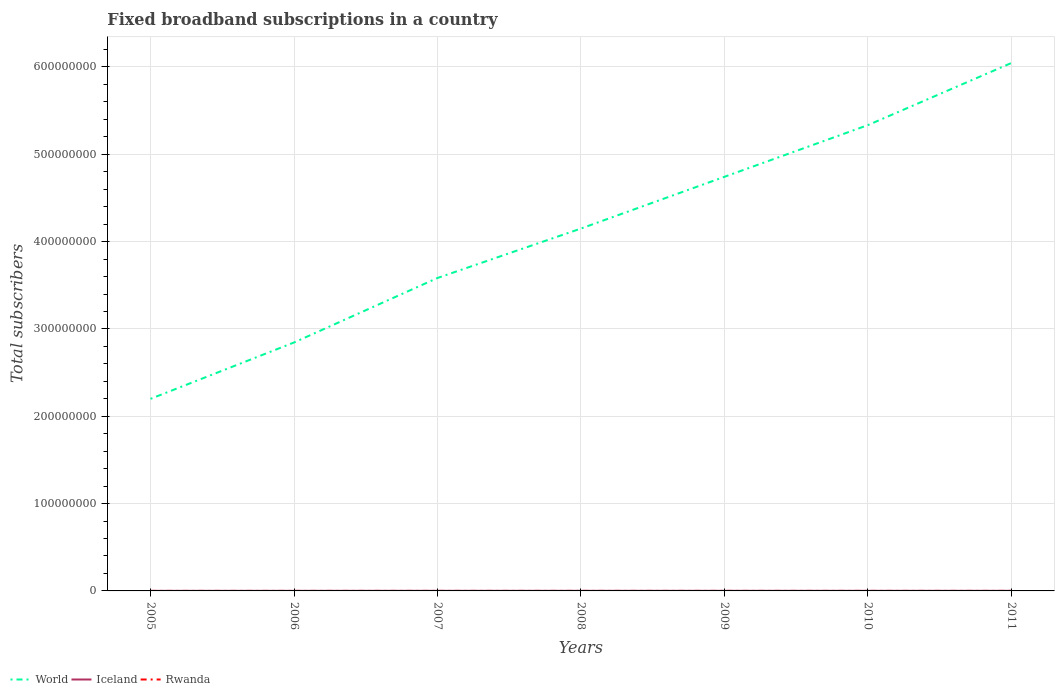Does the line corresponding to Rwanda intersect with the line corresponding to Iceland?
Give a very brief answer. No. Across all years, what is the maximum number of broadband subscriptions in World?
Offer a very short reply. 2.20e+08. What is the total number of broadband subscriptions in Iceland in the graph?
Your answer should be compact. -3.36e+04. What is the difference between the highest and the second highest number of broadband subscriptions in Rwanda?
Provide a succinct answer. 7525. What is the difference between the highest and the lowest number of broadband subscriptions in World?
Your answer should be very brief. 4. Is the number of broadband subscriptions in World strictly greater than the number of broadband subscriptions in Iceland over the years?
Give a very brief answer. No. How many years are there in the graph?
Provide a short and direct response. 7. Are the values on the major ticks of Y-axis written in scientific E-notation?
Your answer should be compact. No. Does the graph contain any zero values?
Your answer should be very brief. No. Does the graph contain grids?
Provide a short and direct response. Yes. Where does the legend appear in the graph?
Your response must be concise. Bottom left. What is the title of the graph?
Give a very brief answer. Fixed broadband subscriptions in a country. Does "Croatia" appear as one of the legend labels in the graph?
Your answer should be compact. No. What is the label or title of the X-axis?
Offer a very short reply. Years. What is the label or title of the Y-axis?
Ensure brevity in your answer.  Total subscribers. What is the Total subscribers of World in 2005?
Your response must be concise. 2.20e+08. What is the Total subscribers in Iceland in 2005?
Give a very brief answer. 7.80e+04. What is the Total subscribers in Rwanda in 2005?
Make the answer very short. 1180. What is the Total subscribers of World in 2006?
Provide a short and direct response. 2.85e+08. What is the Total subscribers in Iceland in 2006?
Keep it short and to the point. 8.77e+04. What is the Total subscribers of Rwanda in 2006?
Offer a very short reply. 1704. What is the Total subscribers of World in 2007?
Your response must be concise. 3.58e+08. What is the Total subscribers of Iceland in 2007?
Provide a short and direct response. 1.00e+05. What is the Total subscribers in Rwanda in 2007?
Your answer should be very brief. 2543. What is the Total subscribers of World in 2008?
Your response must be concise. 4.15e+08. What is the Total subscribers in Iceland in 2008?
Offer a very short reply. 1.06e+05. What is the Total subscribers in Rwanda in 2008?
Give a very brief answer. 1120. What is the Total subscribers in World in 2009?
Provide a short and direct response. 4.74e+08. What is the Total subscribers in Iceland in 2009?
Make the answer very short. 1.07e+05. What is the Total subscribers of Rwanda in 2009?
Offer a terse response. 2214. What is the Total subscribers in World in 2010?
Offer a terse response. 5.33e+08. What is the Total subscribers of Iceland in 2010?
Your answer should be very brief. 1.09e+05. What is the Total subscribers in Rwanda in 2010?
Make the answer very short. 3942. What is the Total subscribers of World in 2011?
Your answer should be very brief. 6.05e+08. What is the Total subscribers of Iceland in 2011?
Ensure brevity in your answer.  1.12e+05. What is the Total subscribers of Rwanda in 2011?
Your answer should be compact. 8645. Across all years, what is the maximum Total subscribers in World?
Your answer should be compact. 6.05e+08. Across all years, what is the maximum Total subscribers of Iceland?
Your response must be concise. 1.12e+05. Across all years, what is the maximum Total subscribers in Rwanda?
Provide a succinct answer. 8645. Across all years, what is the minimum Total subscribers of World?
Your answer should be very brief. 2.20e+08. Across all years, what is the minimum Total subscribers of Iceland?
Offer a terse response. 7.80e+04. Across all years, what is the minimum Total subscribers in Rwanda?
Offer a terse response. 1120. What is the total Total subscribers of World in the graph?
Offer a very short reply. 2.89e+09. What is the total Total subscribers in Iceland in the graph?
Your answer should be very brief. 7.00e+05. What is the total Total subscribers of Rwanda in the graph?
Give a very brief answer. 2.13e+04. What is the difference between the Total subscribers of World in 2005 and that in 2006?
Ensure brevity in your answer.  -6.45e+07. What is the difference between the Total subscribers of Iceland in 2005 and that in 2006?
Offer a terse response. -9721. What is the difference between the Total subscribers in Rwanda in 2005 and that in 2006?
Make the answer very short. -524. What is the difference between the Total subscribers of World in 2005 and that in 2007?
Ensure brevity in your answer.  -1.38e+08. What is the difference between the Total subscribers of Iceland in 2005 and that in 2007?
Offer a terse response. -2.20e+04. What is the difference between the Total subscribers of Rwanda in 2005 and that in 2007?
Your answer should be compact. -1363. What is the difference between the Total subscribers in World in 2005 and that in 2008?
Your response must be concise. -1.95e+08. What is the difference between the Total subscribers in Iceland in 2005 and that in 2008?
Your answer should be very brief. -2.80e+04. What is the difference between the Total subscribers in World in 2005 and that in 2009?
Give a very brief answer. -2.54e+08. What is the difference between the Total subscribers in Iceland in 2005 and that in 2009?
Give a very brief answer. -2.91e+04. What is the difference between the Total subscribers of Rwanda in 2005 and that in 2009?
Give a very brief answer. -1034. What is the difference between the Total subscribers in World in 2005 and that in 2010?
Your answer should be very brief. -3.14e+08. What is the difference between the Total subscribers in Iceland in 2005 and that in 2010?
Your response must be concise. -3.12e+04. What is the difference between the Total subscribers of Rwanda in 2005 and that in 2010?
Ensure brevity in your answer.  -2762. What is the difference between the Total subscribers in World in 2005 and that in 2011?
Your answer should be very brief. -3.85e+08. What is the difference between the Total subscribers in Iceland in 2005 and that in 2011?
Your answer should be compact. -3.36e+04. What is the difference between the Total subscribers in Rwanda in 2005 and that in 2011?
Give a very brief answer. -7465. What is the difference between the Total subscribers of World in 2006 and that in 2007?
Your answer should be very brief. -7.39e+07. What is the difference between the Total subscribers in Iceland in 2006 and that in 2007?
Make the answer very short. -1.23e+04. What is the difference between the Total subscribers in Rwanda in 2006 and that in 2007?
Your answer should be compact. -839. What is the difference between the Total subscribers in World in 2006 and that in 2008?
Provide a succinct answer. -1.31e+08. What is the difference between the Total subscribers of Iceland in 2006 and that in 2008?
Give a very brief answer. -1.83e+04. What is the difference between the Total subscribers of Rwanda in 2006 and that in 2008?
Offer a terse response. 584. What is the difference between the Total subscribers in World in 2006 and that in 2009?
Provide a succinct answer. -1.90e+08. What is the difference between the Total subscribers of Iceland in 2006 and that in 2009?
Your response must be concise. -1.93e+04. What is the difference between the Total subscribers of Rwanda in 2006 and that in 2009?
Your answer should be very brief. -510. What is the difference between the Total subscribers of World in 2006 and that in 2010?
Offer a terse response. -2.49e+08. What is the difference between the Total subscribers in Iceland in 2006 and that in 2010?
Give a very brief answer. -2.15e+04. What is the difference between the Total subscribers of Rwanda in 2006 and that in 2010?
Your answer should be very brief. -2238. What is the difference between the Total subscribers of World in 2006 and that in 2011?
Your response must be concise. -3.20e+08. What is the difference between the Total subscribers of Iceland in 2006 and that in 2011?
Provide a succinct answer. -2.38e+04. What is the difference between the Total subscribers of Rwanda in 2006 and that in 2011?
Your answer should be very brief. -6941. What is the difference between the Total subscribers in World in 2007 and that in 2008?
Provide a short and direct response. -5.66e+07. What is the difference between the Total subscribers of Iceland in 2007 and that in 2008?
Your answer should be very brief. -5991. What is the difference between the Total subscribers of Rwanda in 2007 and that in 2008?
Your response must be concise. 1423. What is the difference between the Total subscribers of World in 2007 and that in 2009?
Make the answer very short. -1.16e+08. What is the difference between the Total subscribers of Iceland in 2007 and that in 2009?
Offer a terse response. -7046. What is the difference between the Total subscribers of Rwanda in 2007 and that in 2009?
Provide a short and direct response. 329. What is the difference between the Total subscribers in World in 2007 and that in 2010?
Offer a terse response. -1.75e+08. What is the difference between the Total subscribers of Iceland in 2007 and that in 2010?
Your answer should be compact. -9186. What is the difference between the Total subscribers in Rwanda in 2007 and that in 2010?
Your response must be concise. -1399. What is the difference between the Total subscribers of World in 2007 and that in 2011?
Offer a very short reply. -2.46e+08. What is the difference between the Total subscribers of Iceland in 2007 and that in 2011?
Your answer should be compact. -1.16e+04. What is the difference between the Total subscribers in Rwanda in 2007 and that in 2011?
Give a very brief answer. -6102. What is the difference between the Total subscribers of World in 2008 and that in 2009?
Provide a short and direct response. -5.92e+07. What is the difference between the Total subscribers of Iceland in 2008 and that in 2009?
Offer a very short reply. -1055. What is the difference between the Total subscribers in Rwanda in 2008 and that in 2009?
Give a very brief answer. -1094. What is the difference between the Total subscribers of World in 2008 and that in 2010?
Your answer should be compact. -1.18e+08. What is the difference between the Total subscribers in Iceland in 2008 and that in 2010?
Offer a terse response. -3195. What is the difference between the Total subscribers of Rwanda in 2008 and that in 2010?
Provide a succinct answer. -2822. What is the difference between the Total subscribers of World in 2008 and that in 2011?
Offer a very short reply. -1.90e+08. What is the difference between the Total subscribers in Iceland in 2008 and that in 2011?
Make the answer very short. -5567. What is the difference between the Total subscribers of Rwanda in 2008 and that in 2011?
Give a very brief answer. -7525. What is the difference between the Total subscribers of World in 2009 and that in 2010?
Offer a terse response. -5.92e+07. What is the difference between the Total subscribers in Iceland in 2009 and that in 2010?
Ensure brevity in your answer.  -2140. What is the difference between the Total subscribers of Rwanda in 2009 and that in 2010?
Ensure brevity in your answer.  -1728. What is the difference between the Total subscribers in World in 2009 and that in 2011?
Make the answer very short. -1.30e+08. What is the difference between the Total subscribers of Iceland in 2009 and that in 2011?
Your answer should be very brief. -4512. What is the difference between the Total subscribers in Rwanda in 2009 and that in 2011?
Offer a very short reply. -6431. What is the difference between the Total subscribers of World in 2010 and that in 2011?
Ensure brevity in your answer.  -7.11e+07. What is the difference between the Total subscribers in Iceland in 2010 and that in 2011?
Keep it short and to the point. -2372. What is the difference between the Total subscribers of Rwanda in 2010 and that in 2011?
Provide a succinct answer. -4703. What is the difference between the Total subscribers in World in 2005 and the Total subscribers in Iceland in 2006?
Your answer should be very brief. 2.20e+08. What is the difference between the Total subscribers in World in 2005 and the Total subscribers in Rwanda in 2006?
Offer a terse response. 2.20e+08. What is the difference between the Total subscribers in Iceland in 2005 and the Total subscribers in Rwanda in 2006?
Your answer should be very brief. 7.63e+04. What is the difference between the Total subscribers in World in 2005 and the Total subscribers in Iceland in 2007?
Your answer should be very brief. 2.20e+08. What is the difference between the Total subscribers in World in 2005 and the Total subscribers in Rwanda in 2007?
Provide a short and direct response. 2.20e+08. What is the difference between the Total subscribers of Iceland in 2005 and the Total subscribers of Rwanda in 2007?
Keep it short and to the point. 7.55e+04. What is the difference between the Total subscribers in World in 2005 and the Total subscribers in Iceland in 2008?
Offer a terse response. 2.20e+08. What is the difference between the Total subscribers of World in 2005 and the Total subscribers of Rwanda in 2008?
Make the answer very short. 2.20e+08. What is the difference between the Total subscribers of Iceland in 2005 and the Total subscribers of Rwanda in 2008?
Provide a short and direct response. 7.69e+04. What is the difference between the Total subscribers in World in 2005 and the Total subscribers in Iceland in 2009?
Your answer should be compact. 2.20e+08. What is the difference between the Total subscribers of World in 2005 and the Total subscribers of Rwanda in 2009?
Your answer should be very brief. 2.20e+08. What is the difference between the Total subscribers of Iceland in 2005 and the Total subscribers of Rwanda in 2009?
Give a very brief answer. 7.58e+04. What is the difference between the Total subscribers in World in 2005 and the Total subscribers in Iceland in 2010?
Make the answer very short. 2.20e+08. What is the difference between the Total subscribers of World in 2005 and the Total subscribers of Rwanda in 2010?
Offer a terse response. 2.20e+08. What is the difference between the Total subscribers in Iceland in 2005 and the Total subscribers in Rwanda in 2010?
Provide a short and direct response. 7.41e+04. What is the difference between the Total subscribers of World in 2005 and the Total subscribers of Iceland in 2011?
Your answer should be compact. 2.20e+08. What is the difference between the Total subscribers in World in 2005 and the Total subscribers in Rwanda in 2011?
Provide a short and direct response. 2.20e+08. What is the difference between the Total subscribers in Iceland in 2005 and the Total subscribers in Rwanda in 2011?
Give a very brief answer. 6.94e+04. What is the difference between the Total subscribers of World in 2006 and the Total subscribers of Iceland in 2007?
Ensure brevity in your answer.  2.84e+08. What is the difference between the Total subscribers of World in 2006 and the Total subscribers of Rwanda in 2007?
Provide a short and direct response. 2.85e+08. What is the difference between the Total subscribers in Iceland in 2006 and the Total subscribers in Rwanda in 2007?
Your answer should be very brief. 8.52e+04. What is the difference between the Total subscribers in World in 2006 and the Total subscribers in Iceland in 2008?
Make the answer very short. 2.84e+08. What is the difference between the Total subscribers of World in 2006 and the Total subscribers of Rwanda in 2008?
Offer a very short reply. 2.85e+08. What is the difference between the Total subscribers in Iceland in 2006 and the Total subscribers in Rwanda in 2008?
Offer a terse response. 8.66e+04. What is the difference between the Total subscribers in World in 2006 and the Total subscribers in Iceland in 2009?
Your response must be concise. 2.84e+08. What is the difference between the Total subscribers of World in 2006 and the Total subscribers of Rwanda in 2009?
Ensure brevity in your answer.  2.85e+08. What is the difference between the Total subscribers of Iceland in 2006 and the Total subscribers of Rwanda in 2009?
Offer a terse response. 8.55e+04. What is the difference between the Total subscribers of World in 2006 and the Total subscribers of Iceland in 2010?
Your answer should be very brief. 2.84e+08. What is the difference between the Total subscribers of World in 2006 and the Total subscribers of Rwanda in 2010?
Make the answer very short. 2.85e+08. What is the difference between the Total subscribers in Iceland in 2006 and the Total subscribers in Rwanda in 2010?
Keep it short and to the point. 8.38e+04. What is the difference between the Total subscribers of World in 2006 and the Total subscribers of Iceland in 2011?
Offer a terse response. 2.84e+08. What is the difference between the Total subscribers of World in 2006 and the Total subscribers of Rwanda in 2011?
Offer a terse response. 2.84e+08. What is the difference between the Total subscribers of Iceland in 2006 and the Total subscribers of Rwanda in 2011?
Ensure brevity in your answer.  7.91e+04. What is the difference between the Total subscribers of World in 2007 and the Total subscribers of Iceland in 2008?
Give a very brief answer. 3.58e+08. What is the difference between the Total subscribers in World in 2007 and the Total subscribers in Rwanda in 2008?
Provide a succinct answer. 3.58e+08. What is the difference between the Total subscribers of Iceland in 2007 and the Total subscribers of Rwanda in 2008?
Your answer should be compact. 9.89e+04. What is the difference between the Total subscribers in World in 2007 and the Total subscribers in Iceland in 2009?
Your answer should be compact. 3.58e+08. What is the difference between the Total subscribers of World in 2007 and the Total subscribers of Rwanda in 2009?
Give a very brief answer. 3.58e+08. What is the difference between the Total subscribers of Iceland in 2007 and the Total subscribers of Rwanda in 2009?
Keep it short and to the point. 9.78e+04. What is the difference between the Total subscribers in World in 2007 and the Total subscribers in Iceland in 2010?
Your answer should be compact. 3.58e+08. What is the difference between the Total subscribers of World in 2007 and the Total subscribers of Rwanda in 2010?
Provide a succinct answer. 3.58e+08. What is the difference between the Total subscribers of Iceland in 2007 and the Total subscribers of Rwanda in 2010?
Your answer should be very brief. 9.61e+04. What is the difference between the Total subscribers of World in 2007 and the Total subscribers of Iceland in 2011?
Your answer should be very brief. 3.58e+08. What is the difference between the Total subscribers in World in 2007 and the Total subscribers in Rwanda in 2011?
Provide a short and direct response. 3.58e+08. What is the difference between the Total subscribers of Iceland in 2007 and the Total subscribers of Rwanda in 2011?
Provide a succinct answer. 9.14e+04. What is the difference between the Total subscribers of World in 2008 and the Total subscribers of Iceland in 2009?
Keep it short and to the point. 4.15e+08. What is the difference between the Total subscribers in World in 2008 and the Total subscribers in Rwanda in 2009?
Make the answer very short. 4.15e+08. What is the difference between the Total subscribers in Iceland in 2008 and the Total subscribers in Rwanda in 2009?
Offer a terse response. 1.04e+05. What is the difference between the Total subscribers in World in 2008 and the Total subscribers in Iceland in 2010?
Ensure brevity in your answer.  4.15e+08. What is the difference between the Total subscribers in World in 2008 and the Total subscribers in Rwanda in 2010?
Provide a succinct answer. 4.15e+08. What is the difference between the Total subscribers in Iceland in 2008 and the Total subscribers in Rwanda in 2010?
Your response must be concise. 1.02e+05. What is the difference between the Total subscribers in World in 2008 and the Total subscribers in Iceland in 2011?
Your answer should be compact. 4.15e+08. What is the difference between the Total subscribers of World in 2008 and the Total subscribers of Rwanda in 2011?
Provide a short and direct response. 4.15e+08. What is the difference between the Total subscribers in Iceland in 2008 and the Total subscribers in Rwanda in 2011?
Ensure brevity in your answer.  9.74e+04. What is the difference between the Total subscribers in World in 2009 and the Total subscribers in Iceland in 2010?
Ensure brevity in your answer.  4.74e+08. What is the difference between the Total subscribers in World in 2009 and the Total subscribers in Rwanda in 2010?
Provide a short and direct response. 4.74e+08. What is the difference between the Total subscribers in Iceland in 2009 and the Total subscribers in Rwanda in 2010?
Your answer should be compact. 1.03e+05. What is the difference between the Total subscribers of World in 2009 and the Total subscribers of Iceland in 2011?
Offer a terse response. 4.74e+08. What is the difference between the Total subscribers of World in 2009 and the Total subscribers of Rwanda in 2011?
Ensure brevity in your answer.  4.74e+08. What is the difference between the Total subscribers of Iceland in 2009 and the Total subscribers of Rwanda in 2011?
Provide a succinct answer. 9.84e+04. What is the difference between the Total subscribers of World in 2010 and the Total subscribers of Iceland in 2011?
Your answer should be compact. 5.33e+08. What is the difference between the Total subscribers in World in 2010 and the Total subscribers in Rwanda in 2011?
Give a very brief answer. 5.33e+08. What is the difference between the Total subscribers of Iceland in 2010 and the Total subscribers of Rwanda in 2011?
Make the answer very short. 1.01e+05. What is the average Total subscribers in World per year?
Provide a succinct answer. 4.13e+08. What is the average Total subscribers of Iceland per year?
Your answer should be compact. 1.00e+05. What is the average Total subscribers in Rwanda per year?
Your answer should be very brief. 3049.71. In the year 2005, what is the difference between the Total subscribers in World and Total subscribers in Iceland?
Keep it short and to the point. 2.20e+08. In the year 2005, what is the difference between the Total subscribers in World and Total subscribers in Rwanda?
Keep it short and to the point. 2.20e+08. In the year 2005, what is the difference between the Total subscribers in Iceland and Total subscribers in Rwanda?
Provide a succinct answer. 7.68e+04. In the year 2006, what is the difference between the Total subscribers of World and Total subscribers of Iceland?
Provide a short and direct response. 2.84e+08. In the year 2006, what is the difference between the Total subscribers of World and Total subscribers of Rwanda?
Provide a succinct answer. 2.85e+08. In the year 2006, what is the difference between the Total subscribers of Iceland and Total subscribers of Rwanda?
Your response must be concise. 8.60e+04. In the year 2007, what is the difference between the Total subscribers in World and Total subscribers in Iceland?
Offer a terse response. 3.58e+08. In the year 2007, what is the difference between the Total subscribers in World and Total subscribers in Rwanda?
Offer a terse response. 3.58e+08. In the year 2007, what is the difference between the Total subscribers in Iceland and Total subscribers in Rwanda?
Keep it short and to the point. 9.75e+04. In the year 2008, what is the difference between the Total subscribers of World and Total subscribers of Iceland?
Offer a terse response. 4.15e+08. In the year 2008, what is the difference between the Total subscribers of World and Total subscribers of Rwanda?
Provide a succinct answer. 4.15e+08. In the year 2008, what is the difference between the Total subscribers of Iceland and Total subscribers of Rwanda?
Ensure brevity in your answer.  1.05e+05. In the year 2009, what is the difference between the Total subscribers of World and Total subscribers of Iceland?
Keep it short and to the point. 4.74e+08. In the year 2009, what is the difference between the Total subscribers in World and Total subscribers in Rwanda?
Your answer should be very brief. 4.74e+08. In the year 2009, what is the difference between the Total subscribers in Iceland and Total subscribers in Rwanda?
Offer a very short reply. 1.05e+05. In the year 2010, what is the difference between the Total subscribers of World and Total subscribers of Iceland?
Provide a succinct answer. 5.33e+08. In the year 2010, what is the difference between the Total subscribers in World and Total subscribers in Rwanda?
Offer a very short reply. 5.33e+08. In the year 2010, what is the difference between the Total subscribers in Iceland and Total subscribers in Rwanda?
Ensure brevity in your answer.  1.05e+05. In the year 2011, what is the difference between the Total subscribers of World and Total subscribers of Iceland?
Provide a short and direct response. 6.04e+08. In the year 2011, what is the difference between the Total subscribers in World and Total subscribers in Rwanda?
Ensure brevity in your answer.  6.05e+08. In the year 2011, what is the difference between the Total subscribers of Iceland and Total subscribers of Rwanda?
Your answer should be very brief. 1.03e+05. What is the ratio of the Total subscribers of World in 2005 to that in 2006?
Provide a succinct answer. 0.77. What is the ratio of the Total subscribers in Iceland in 2005 to that in 2006?
Provide a succinct answer. 0.89. What is the ratio of the Total subscribers of Rwanda in 2005 to that in 2006?
Your answer should be very brief. 0.69. What is the ratio of the Total subscribers of World in 2005 to that in 2007?
Your answer should be very brief. 0.61. What is the ratio of the Total subscribers in Iceland in 2005 to that in 2007?
Give a very brief answer. 0.78. What is the ratio of the Total subscribers in Rwanda in 2005 to that in 2007?
Keep it short and to the point. 0.46. What is the ratio of the Total subscribers in World in 2005 to that in 2008?
Provide a short and direct response. 0.53. What is the ratio of the Total subscribers in Iceland in 2005 to that in 2008?
Your answer should be very brief. 0.74. What is the ratio of the Total subscribers of Rwanda in 2005 to that in 2008?
Offer a terse response. 1.05. What is the ratio of the Total subscribers in World in 2005 to that in 2009?
Offer a very short reply. 0.46. What is the ratio of the Total subscribers in Iceland in 2005 to that in 2009?
Provide a short and direct response. 0.73. What is the ratio of the Total subscribers in Rwanda in 2005 to that in 2009?
Your response must be concise. 0.53. What is the ratio of the Total subscribers of World in 2005 to that in 2010?
Your answer should be very brief. 0.41. What is the ratio of the Total subscribers in Iceland in 2005 to that in 2010?
Provide a succinct answer. 0.71. What is the ratio of the Total subscribers of Rwanda in 2005 to that in 2010?
Ensure brevity in your answer.  0.3. What is the ratio of the Total subscribers in World in 2005 to that in 2011?
Your answer should be compact. 0.36. What is the ratio of the Total subscribers of Iceland in 2005 to that in 2011?
Your answer should be compact. 0.7. What is the ratio of the Total subscribers of Rwanda in 2005 to that in 2011?
Give a very brief answer. 0.14. What is the ratio of the Total subscribers in World in 2006 to that in 2007?
Provide a succinct answer. 0.79. What is the ratio of the Total subscribers of Iceland in 2006 to that in 2007?
Make the answer very short. 0.88. What is the ratio of the Total subscribers of Rwanda in 2006 to that in 2007?
Offer a terse response. 0.67. What is the ratio of the Total subscribers of World in 2006 to that in 2008?
Keep it short and to the point. 0.69. What is the ratio of the Total subscribers of Iceland in 2006 to that in 2008?
Give a very brief answer. 0.83. What is the ratio of the Total subscribers of Rwanda in 2006 to that in 2008?
Offer a very short reply. 1.52. What is the ratio of the Total subscribers of World in 2006 to that in 2009?
Your answer should be compact. 0.6. What is the ratio of the Total subscribers of Iceland in 2006 to that in 2009?
Provide a short and direct response. 0.82. What is the ratio of the Total subscribers in Rwanda in 2006 to that in 2009?
Your answer should be very brief. 0.77. What is the ratio of the Total subscribers of World in 2006 to that in 2010?
Give a very brief answer. 0.53. What is the ratio of the Total subscribers of Iceland in 2006 to that in 2010?
Your answer should be compact. 0.8. What is the ratio of the Total subscribers in Rwanda in 2006 to that in 2010?
Ensure brevity in your answer.  0.43. What is the ratio of the Total subscribers of World in 2006 to that in 2011?
Your answer should be very brief. 0.47. What is the ratio of the Total subscribers in Iceland in 2006 to that in 2011?
Your response must be concise. 0.79. What is the ratio of the Total subscribers of Rwanda in 2006 to that in 2011?
Keep it short and to the point. 0.2. What is the ratio of the Total subscribers in World in 2007 to that in 2008?
Your answer should be very brief. 0.86. What is the ratio of the Total subscribers of Iceland in 2007 to that in 2008?
Offer a very short reply. 0.94. What is the ratio of the Total subscribers of Rwanda in 2007 to that in 2008?
Keep it short and to the point. 2.27. What is the ratio of the Total subscribers of World in 2007 to that in 2009?
Provide a short and direct response. 0.76. What is the ratio of the Total subscribers of Iceland in 2007 to that in 2009?
Give a very brief answer. 0.93. What is the ratio of the Total subscribers in Rwanda in 2007 to that in 2009?
Provide a succinct answer. 1.15. What is the ratio of the Total subscribers of World in 2007 to that in 2010?
Make the answer very short. 0.67. What is the ratio of the Total subscribers of Iceland in 2007 to that in 2010?
Give a very brief answer. 0.92. What is the ratio of the Total subscribers of Rwanda in 2007 to that in 2010?
Provide a succinct answer. 0.65. What is the ratio of the Total subscribers in World in 2007 to that in 2011?
Offer a terse response. 0.59. What is the ratio of the Total subscribers of Iceland in 2007 to that in 2011?
Offer a very short reply. 0.9. What is the ratio of the Total subscribers of Rwanda in 2007 to that in 2011?
Your answer should be very brief. 0.29. What is the ratio of the Total subscribers in World in 2008 to that in 2009?
Provide a succinct answer. 0.88. What is the ratio of the Total subscribers in Rwanda in 2008 to that in 2009?
Keep it short and to the point. 0.51. What is the ratio of the Total subscribers in World in 2008 to that in 2010?
Give a very brief answer. 0.78. What is the ratio of the Total subscribers in Iceland in 2008 to that in 2010?
Ensure brevity in your answer.  0.97. What is the ratio of the Total subscribers of Rwanda in 2008 to that in 2010?
Offer a terse response. 0.28. What is the ratio of the Total subscribers in World in 2008 to that in 2011?
Ensure brevity in your answer.  0.69. What is the ratio of the Total subscribers of Iceland in 2008 to that in 2011?
Make the answer very short. 0.95. What is the ratio of the Total subscribers in Rwanda in 2008 to that in 2011?
Your response must be concise. 0.13. What is the ratio of the Total subscribers of World in 2009 to that in 2010?
Ensure brevity in your answer.  0.89. What is the ratio of the Total subscribers of Iceland in 2009 to that in 2010?
Provide a succinct answer. 0.98. What is the ratio of the Total subscribers in Rwanda in 2009 to that in 2010?
Offer a terse response. 0.56. What is the ratio of the Total subscribers in World in 2009 to that in 2011?
Provide a succinct answer. 0.78. What is the ratio of the Total subscribers of Iceland in 2009 to that in 2011?
Offer a terse response. 0.96. What is the ratio of the Total subscribers of Rwanda in 2009 to that in 2011?
Ensure brevity in your answer.  0.26. What is the ratio of the Total subscribers of World in 2010 to that in 2011?
Offer a very short reply. 0.88. What is the ratio of the Total subscribers in Iceland in 2010 to that in 2011?
Ensure brevity in your answer.  0.98. What is the ratio of the Total subscribers in Rwanda in 2010 to that in 2011?
Your answer should be compact. 0.46. What is the difference between the highest and the second highest Total subscribers of World?
Your answer should be compact. 7.11e+07. What is the difference between the highest and the second highest Total subscribers of Iceland?
Offer a very short reply. 2372. What is the difference between the highest and the second highest Total subscribers in Rwanda?
Ensure brevity in your answer.  4703. What is the difference between the highest and the lowest Total subscribers of World?
Your answer should be compact. 3.85e+08. What is the difference between the highest and the lowest Total subscribers of Iceland?
Ensure brevity in your answer.  3.36e+04. What is the difference between the highest and the lowest Total subscribers in Rwanda?
Your answer should be compact. 7525. 